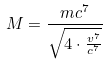Convert formula to latex. <formula><loc_0><loc_0><loc_500><loc_500>M = \frac { m c ^ { 7 } } { \sqrt { 4 \cdot \frac { v ^ { 7 } } { c ^ { 7 } } } }</formula> 